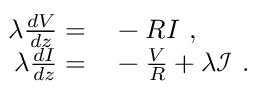<formula> <loc_0><loc_0><loc_500><loc_500>\begin{array} { r l } { \lambda \frac { d V } { d z } = } & - R I , } \\ { \lambda \frac { d I } { d z } = } & - \frac { V } { R } + \lambda \mathcal { I } . } \end{array}</formula> 